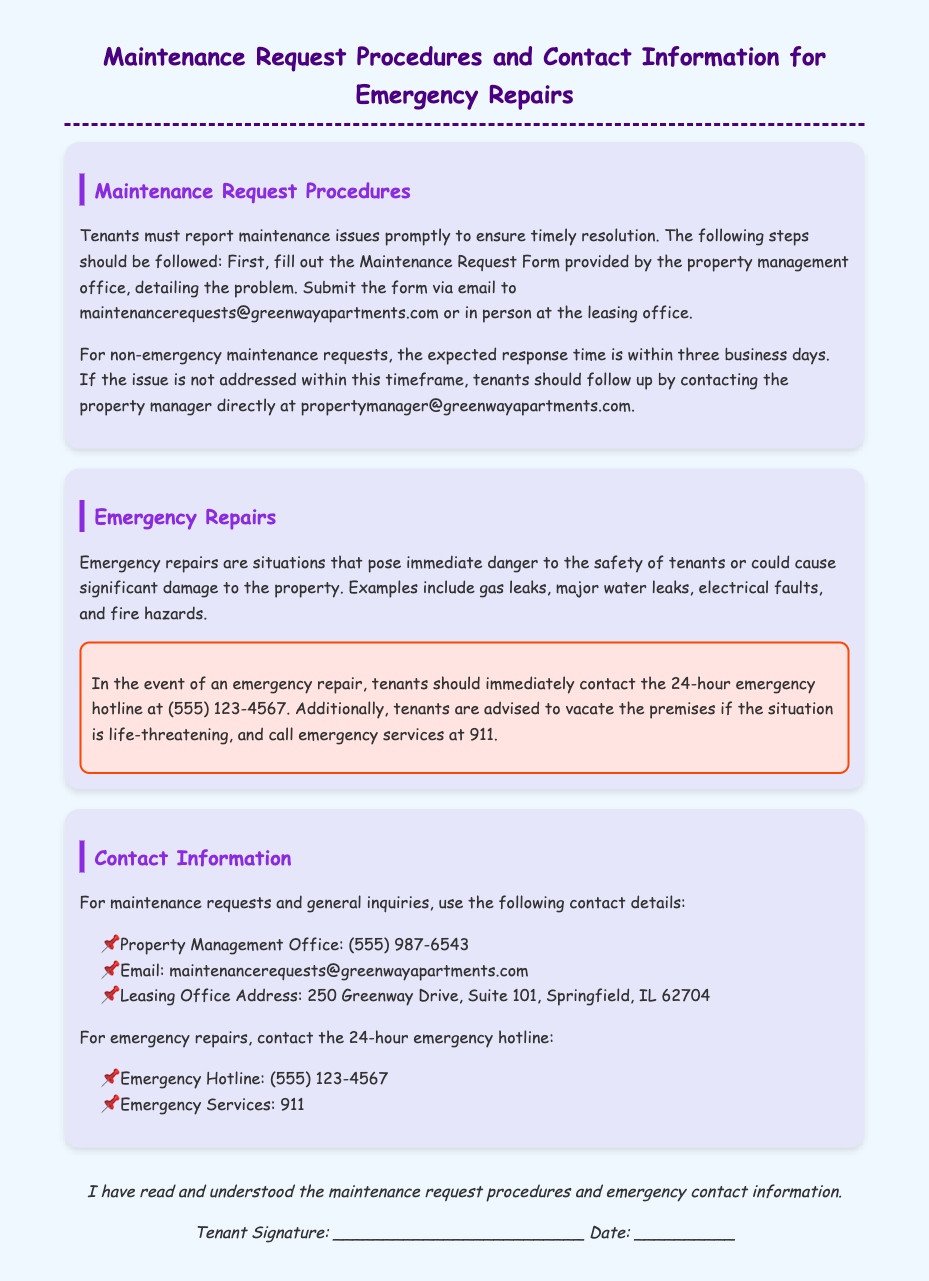What is the email for maintenance requests? The document specifies the email for maintenance requests as maintenancerequests@greenwayapartments.com.
Answer: maintenancerequests@greenwayapartments.com What is the response time for non-emergency maintenance requests? The expected response time for non-emergency maintenance requests is detailed in the document. It states that the response time is within three business days.
Answer: three business days What phone number should tenants call for emergency repairs? Tenants are instructed to call the 24-hour emergency hotline at (555) 123-4567 for emergency repairs.
Answer: (555) 123-4567 What should tenants do if they encounter a gas leak? The document indicates that a gas leak qualifies as an emergency repair, and tenants should contact the emergency hotline immediately.
Answer: contact the emergency hotline What is the leasing office address? The leasing office address is mentioned in the contact information section of the document. It states 250 Greenway Drive, Suite 101, Springfield, IL 62704.
Answer: 250 Greenway Drive, Suite 101, Springfield, IL 62704 